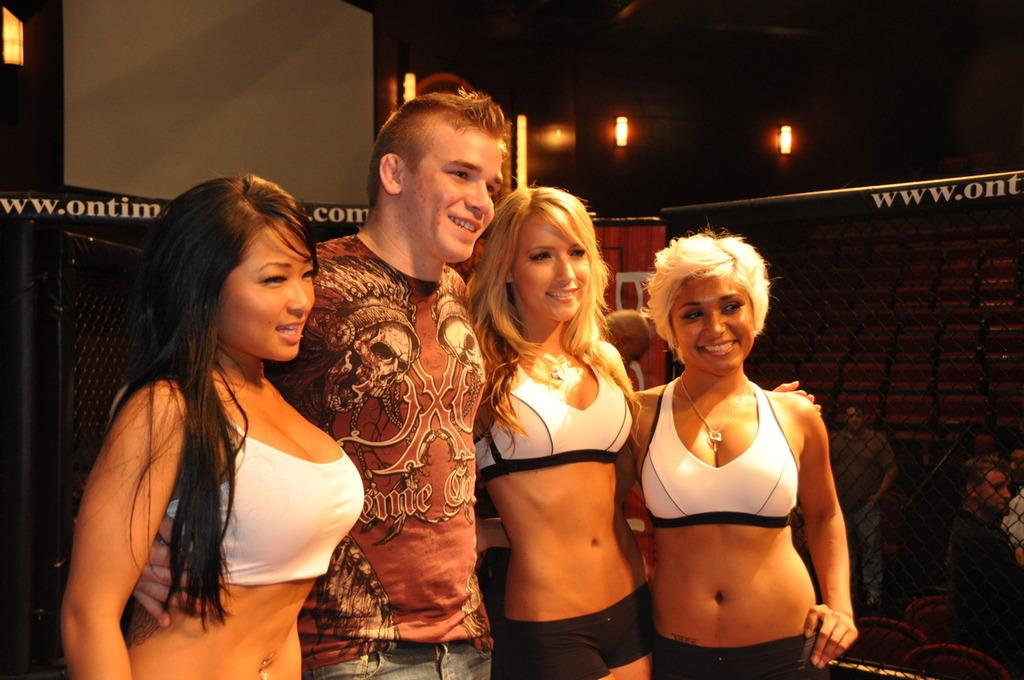What is the main subject of the image? There is a person standing in the image. Can you describe the people on the right side of the image? There are people behind a fence on the right side of the image. What is attached to the wall in the image? Lights are attached to a wall in the image. What is present on the left side of the image? There is a fence on the left side of the image. Can you tell me how many bees are flying around the person in the image? There are no bees present in the image. What type of walk is the person taking in the image? The image does not show the person walking; they are standing still. 